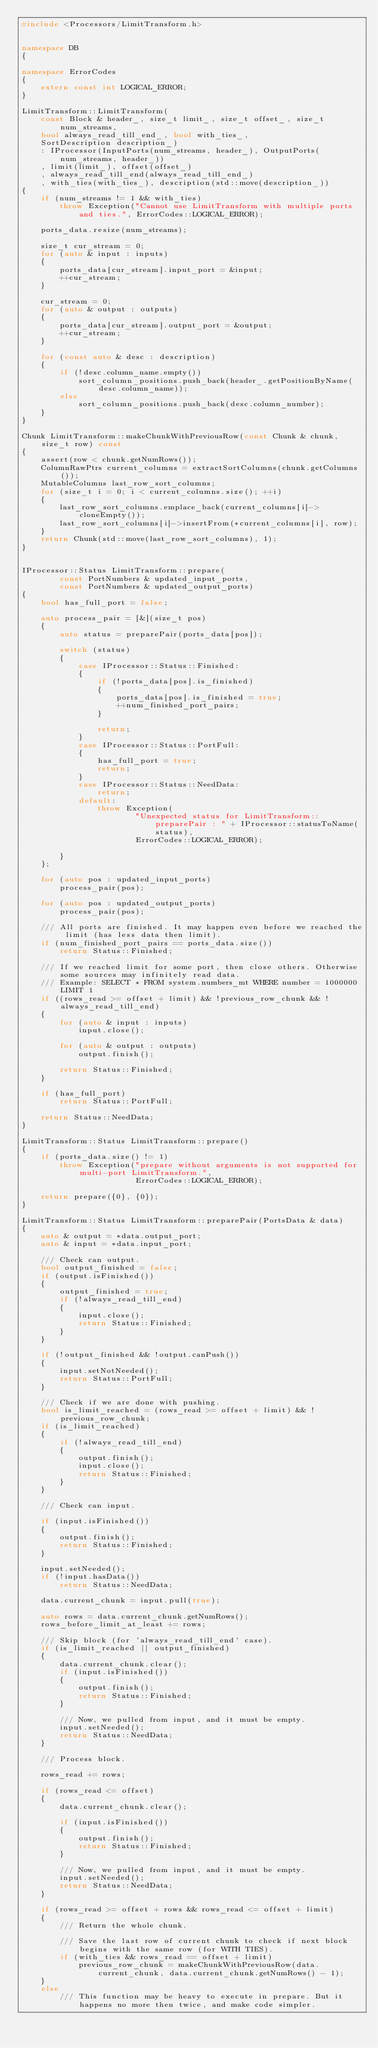Convert code to text. <code><loc_0><loc_0><loc_500><loc_500><_C++_>#include <Processors/LimitTransform.h>


namespace DB
{

namespace ErrorCodes
{
    extern const int LOGICAL_ERROR;
}

LimitTransform::LimitTransform(
    const Block & header_, size_t limit_, size_t offset_, size_t num_streams,
    bool always_read_till_end_, bool with_ties_,
    SortDescription description_)
    : IProcessor(InputPorts(num_streams, header_), OutputPorts(num_streams, header_))
    , limit(limit_), offset(offset_)
    , always_read_till_end(always_read_till_end_)
    , with_ties(with_ties_), description(std::move(description_))
{
    if (num_streams != 1 && with_ties)
        throw Exception("Cannot use LimitTransform with multiple ports and ties.", ErrorCodes::LOGICAL_ERROR);

    ports_data.resize(num_streams);

    size_t cur_stream = 0;
    for (auto & input : inputs)
    {
        ports_data[cur_stream].input_port = &input;
        ++cur_stream;
    }

    cur_stream = 0;
    for (auto & output : outputs)
    {
        ports_data[cur_stream].output_port = &output;
        ++cur_stream;
    }

    for (const auto & desc : description)
    {
        if (!desc.column_name.empty())
            sort_column_positions.push_back(header_.getPositionByName(desc.column_name));
        else
            sort_column_positions.push_back(desc.column_number);
    }
}

Chunk LimitTransform::makeChunkWithPreviousRow(const Chunk & chunk, size_t row) const
{
    assert(row < chunk.getNumRows());
    ColumnRawPtrs current_columns = extractSortColumns(chunk.getColumns());
    MutableColumns last_row_sort_columns;
    for (size_t i = 0; i < current_columns.size(); ++i)
    {
        last_row_sort_columns.emplace_back(current_columns[i]->cloneEmpty());
        last_row_sort_columns[i]->insertFrom(*current_columns[i], row);
    }
    return Chunk(std::move(last_row_sort_columns), 1);
}


IProcessor::Status LimitTransform::prepare(
        const PortNumbers & updated_input_ports,
        const PortNumbers & updated_output_ports)
{
    bool has_full_port = false;

    auto process_pair = [&](size_t pos)
    {
        auto status = preparePair(ports_data[pos]);

        switch (status)
        {
            case IProcessor::Status::Finished:
            {
                if (!ports_data[pos].is_finished)
                {
                    ports_data[pos].is_finished = true;
                    ++num_finished_port_pairs;
                }

                return;
            }
            case IProcessor::Status::PortFull:
            {
                has_full_port = true;
                return;
            }
            case IProcessor::Status::NeedData:
                return;
            default:
                throw Exception(
                        "Unexpected status for LimitTransform::preparePair : " + IProcessor::statusToName(status),
                        ErrorCodes::LOGICAL_ERROR);

        }
    };

    for (auto pos : updated_input_ports)
        process_pair(pos);

    for (auto pos : updated_output_ports)
        process_pair(pos);

    /// All ports are finished. It may happen even before we reached the limit (has less data then limit).
    if (num_finished_port_pairs == ports_data.size())
        return Status::Finished;

    /// If we reached limit for some port, then close others. Otherwise some sources may infinitely read data.
    /// Example: SELECT * FROM system.numbers_mt WHERE number = 1000000 LIMIT 1
    if ((rows_read >= offset + limit) && !previous_row_chunk && !always_read_till_end)
    {
        for (auto & input : inputs)
            input.close();

        for (auto & output : outputs)
            output.finish();

        return Status::Finished;
    }

    if (has_full_port)
        return Status::PortFull;

    return Status::NeedData;
}

LimitTransform::Status LimitTransform::prepare()
{
    if (ports_data.size() != 1)
        throw Exception("prepare without arguments is not supported for multi-port LimitTransform.",
                        ErrorCodes::LOGICAL_ERROR);

    return prepare({0}, {0});
}

LimitTransform::Status LimitTransform::preparePair(PortsData & data)
{
    auto & output = *data.output_port;
    auto & input = *data.input_port;

    /// Check can output.
    bool output_finished = false;
    if (output.isFinished())
    {
        output_finished = true;
        if (!always_read_till_end)
        {
            input.close();
            return Status::Finished;
        }
    }

    if (!output_finished && !output.canPush())
    {
        input.setNotNeeded();
        return Status::PortFull;
    }

    /// Check if we are done with pushing.
    bool is_limit_reached = (rows_read >= offset + limit) && !previous_row_chunk;
    if (is_limit_reached)
    {
        if (!always_read_till_end)
        {
            output.finish();
            input.close();
            return Status::Finished;
        }
    }

    /// Check can input.

    if (input.isFinished())
    {
        output.finish();
        return Status::Finished;
    }

    input.setNeeded();
    if (!input.hasData())
        return Status::NeedData;

    data.current_chunk = input.pull(true);

    auto rows = data.current_chunk.getNumRows();
    rows_before_limit_at_least += rows;

    /// Skip block (for 'always_read_till_end' case).
    if (is_limit_reached || output_finished)
    {
        data.current_chunk.clear();
        if (input.isFinished())
        {
            output.finish();
            return Status::Finished;
        }

        /// Now, we pulled from input, and it must be empty.
        input.setNeeded();
        return Status::NeedData;
    }

    /// Process block.

    rows_read += rows;

    if (rows_read <= offset)
    {
        data.current_chunk.clear();

        if (input.isFinished())
        {
            output.finish();
            return Status::Finished;
        }

        /// Now, we pulled from input, and it must be empty.
        input.setNeeded();
        return Status::NeedData;
    }

    if (rows_read >= offset + rows && rows_read <= offset + limit)
    {
        /// Return the whole chunk.

        /// Save the last row of current chunk to check if next block begins with the same row (for WITH TIES).
        if (with_ties && rows_read == offset + limit)
            previous_row_chunk = makeChunkWithPreviousRow(data.current_chunk, data.current_chunk.getNumRows() - 1);
    }
    else
        /// This function may be heavy to execute in prepare. But it happens no more then twice, and make code simpler.</code> 